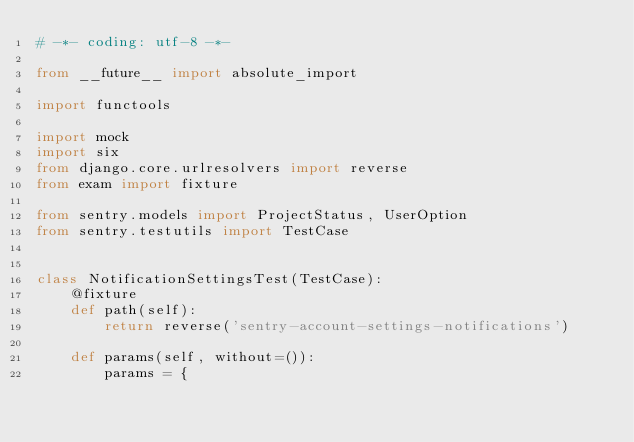<code> <loc_0><loc_0><loc_500><loc_500><_Python_># -*- coding: utf-8 -*-

from __future__ import absolute_import

import functools

import mock
import six
from django.core.urlresolvers import reverse
from exam import fixture

from sentry.models import ProjectStatus, UserOption
from sentry.testutils import TestCase


class NotificationSettingsTest(TestCase):
    @fixture
    def path(self):
        return reverse('sentry-account-settings-notifications')

    def params(self, without=()):
        params = {</code> 